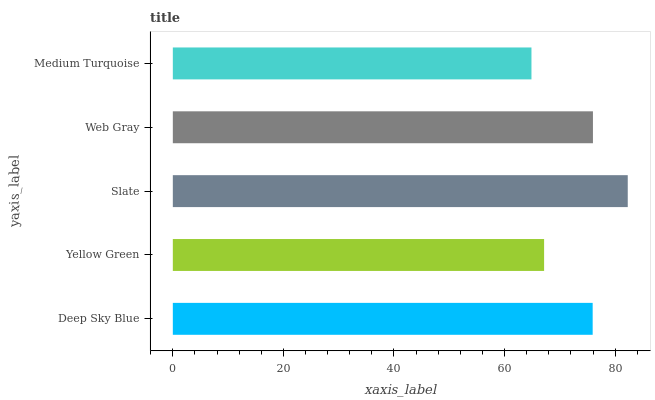Is Medium Turquoise the minimum?
Answer yes or no. Yes. Is Slate the maximum?
Answer yes or no. Yes. Is Yellow Green the minimum?
Answer yes or no. No. Is Yellow Green the maximum?
Answer yes or no. No. Is Deep Sky Blue greater than Yellow Green?
Answer yes or no. Yes. Is Yellow Green less than Deep Sky Blue?
Answer yes or no. Yes. Is Yellow Green greater than Deep Sky Blue?
Answer yes or no. No. Is Deep Sky Blue less than Yellow Green?
Answer yes or no. No. Is Deep Sky Blue the high median?
Answer yes or no. Yes. Is Deep Sky Blue the low median?
Answer yes or no. Yes. Is Web Gray the high median?
Answer yes or no. No. Is Slate the low median?
Answer yes or no. No. 